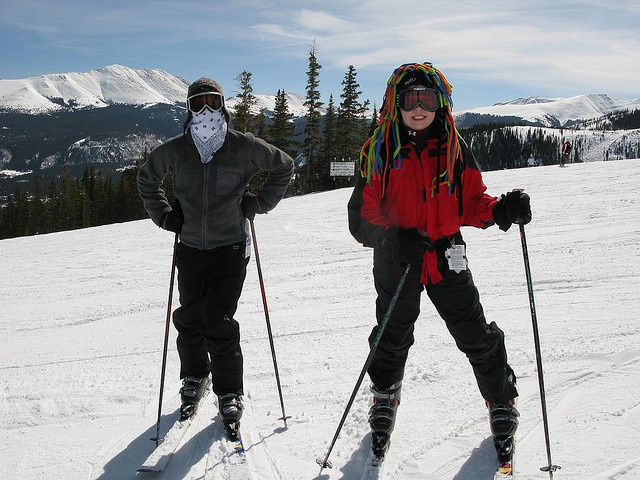Describe the objects in this image and their specific colors. I can see people in gray, black, maroon, and lightgray tones, people in gray, black, darkgray, and lightgray tones, skis in gray, lightgray, darkgray, and black tones, and skis in gray, black, and lightgray tones in this image. 